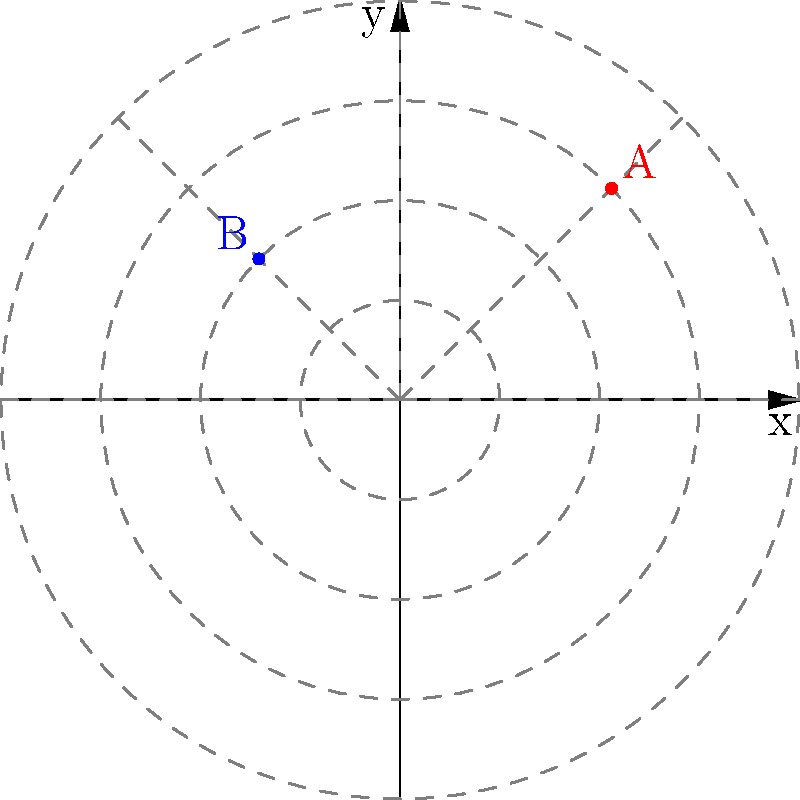In a yoga balance pose, your right foot (point A) is placed at $(3\cos(\frac{\pi}{4}), 3\sin(\frac{\pi}{4}))$ and your left hand (point B) is at $(2\cos(\frac{3\pi}{4}), 2\sin(\frac{3\pi}{4}))$ in polar coordinates. What is the difference between the radial distances of your right foot and left hand from the center of balance? To find the difference between the radial distances, we need to:

1. Identify the radial distances (r) for both points:
   - Point A (right foot): $r_A = 3$
   - Point B (left hand): $r_B = 2$

2. Calculate the difference:
   $\text{Difference} = r_A - r_B = 3 - 2 = 1$

The radial distance represents the distance from the center of balance (origin) to the point in question. In this yoga pose, your right foot is placed further from the center than your left hand.

This difference in radial distance can affect your balance and stability in the pose, as well as the engagement of different muscle groups. As an actress focusing on vocal performance, understanding this balance can help you maintain proper posture and breath control during challenging poses, which can translate to better vocal projection and control on stage.
Answer: 1 unit 